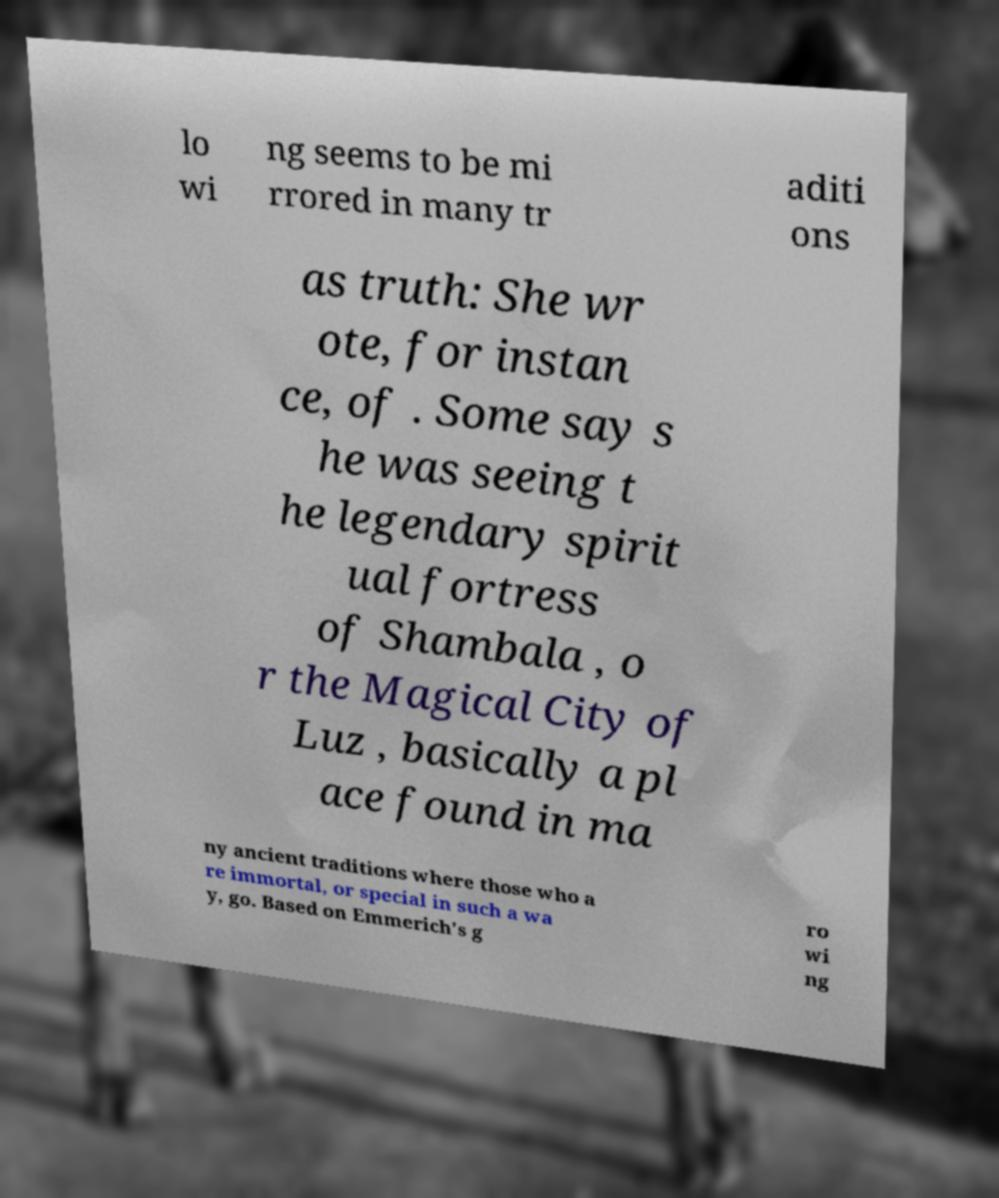What messages or text are displayed in this image? I need them in a readable, typed format. lo wi ng seems to be mi rrored in many tr aditi ons as truth: She wr ote, for instan ce, of . Some say s he was seeing t he legendary spirit ual fortress of Shambala , o r the Magical City of Luz , basically a pl ace found in ma ny ancient traditions where those who a re immortal, or special in such a wa y, go. Based on Emmerich's g ro wi ng 